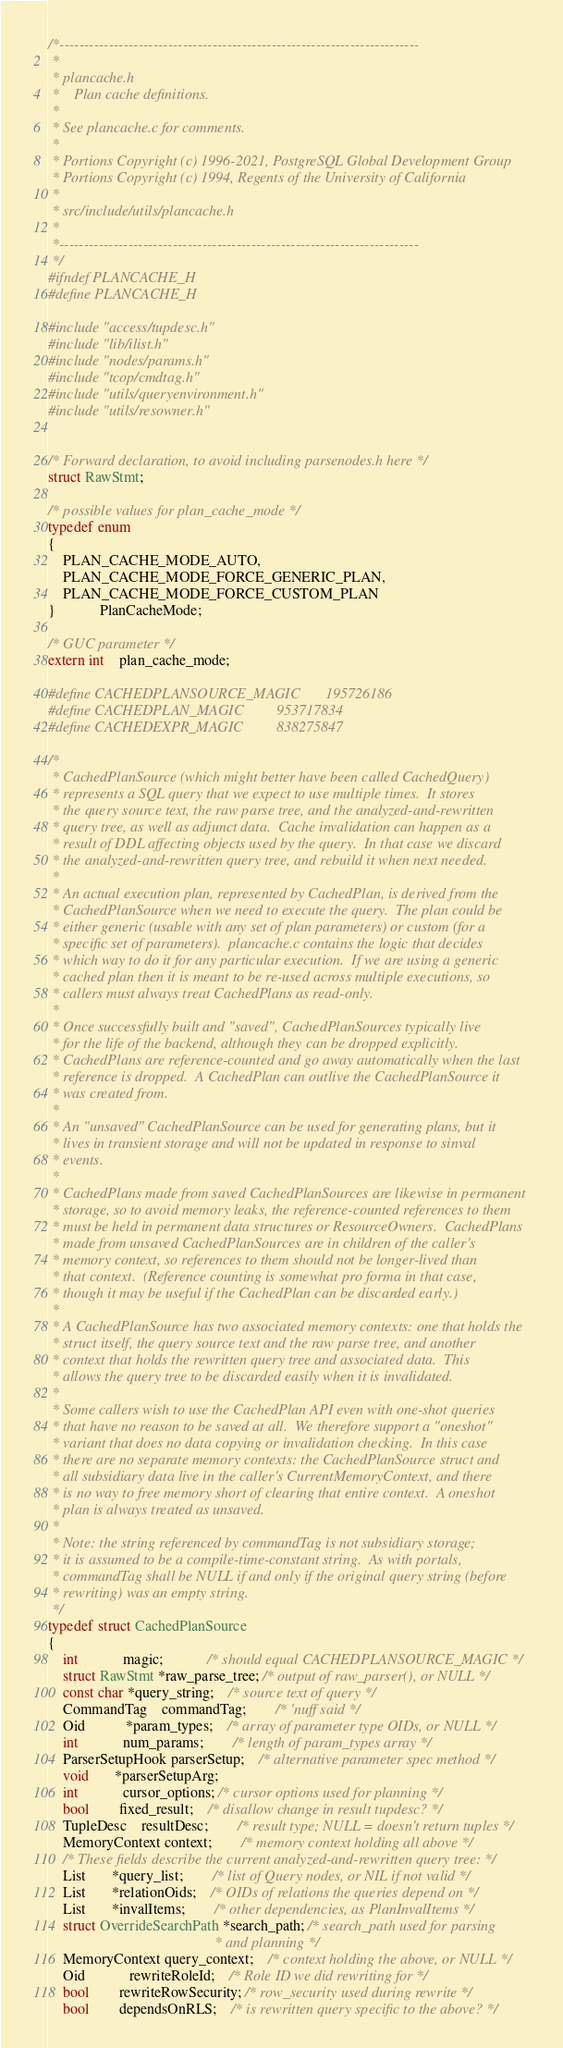<code> <loc_0><loc_0><loc_500><loc_500><_C_>/*-------------------------------------------------------------------------
 *
 * plancache.h
 *	  Plan cache definitions.
 *
 * See plancache.c for comments.
 *
 * Portions Copyright (c) 1996-2021, PostgreSQL Global Development Group
 * Portions Copyright (c) 1994, Regents of the University of California
 *
 * src/include/utils/plancache.h
 *
 *-------------------------------------------------------------------------
 */
#ifndef PLANCACHE_H
#define PLANCACHE_H

#include "access/tupdesc.h"
#include "lib/ilist.h"
#include "nodes/params.h"
#include "tcop/cmdtag.h"
#include "utils/queryenvironment.h"
#include "utils/resowner.h"


/* Forward declaration, to avoid including parsenodes.h here */
struct RawStmt;

/* possible values for plan_cache_mode */
typedef enum
{
	PLAN_CACHE_MODE_AUTO,
	PLAN_CACHE_MODE_FORCE_GENERIC_PLAN,
	PLAN_CACHE_MODE_FORCE_CUSTOM_PLAN
}			PlanCacheMode;

/* GUC parameter */
extern int	plan_cache_mode;

#define CACHEDPLANSOURCE_MAGIC		195726186
#define CACHEDPLAN_MAGIC			953717834
#define CACHEDEXPR_MAGIC			838275847

/*
 * CachedPlanSource (which might better have been called CachedQuery)
 * represents a SQL query that we expect to use multiple times.  It stores
 * the query source text, the raw parse tree, and the analyzed-and-rewritten
 * query tree, as well as adjunct data.  Cache invalidation can happen as a
 * result of DDL affecting objects used by the query.  In that case we discard
 * the analyzed-and-rewritten query tree, and rebuild it when next needed.
 *
 * An actual execution plan, represented by CachedPlan, is derived from the
 * CachedPlanSource when we need to execute the query.  The plan could be
 * either generic (usable with any set of plan parameters) or custom (for a
 * specific set of parameters).  plancache.c contains the logic that decides
 * which way to do it for any particular execution.  If we are using a generic
 * cached plan then it is meant to be re-used across multiple executions, so
 * callers must always treat CachedPlans as read-only.
 *
 * Once successfully built and "saved", CachedPlanSources typically live
 * for the life of the backend, although they can be dropped explicitly.
 * CachedPlans are reference-counted and go away automatically when the last
 * reference is dropped.  A CachedPlan can outlive the CachedPlanSource it
 * was created from.
 *
 * An "unsaved" CachedPlanSource can be used for generating plans, but it
 * lives in transient storage and will not be updated in response to sinval
 * events.
 *
 * CachedPlans made from saved CachedPlanSources are likewise in permanent
 * storage, so to avoid memory leaks, the reference-counted references to them
 * must be held in permanent data structures or ResourceOwners.  CachedPlans
 * made from unsaved CachedPlanSources are in children of the caller's
 * memory context, so references to them should not be longer-lived than
 * that context.  (Reference counting is somewhat pro forma in that case,
 * though it may be useful if the CachedPlan can be discarded early.)
 *
 * A CachedPlanSource has two associated memory contexts: one that holds the
 * struct itself, the query source text and the raw parse tree, and another
 * context that holds the rewritten query tree and associated data.  This
 * allows the query tree to be discarded easily when it is invalidated.
 *
 * Some callers wish to use the CachedPlan API even with one-shot queries
 * that have no reason to be saved at all.  We therefore support a "oneshot"
 * variant that does no data copying or invalidation checking.  In this case
 * there are no separate memory contexts: the CachedPlanSource struct and
 * all subsidiary data live in the caller's CurrentMemoryContext, and there
 * is no way to free memory short of clearing that entire context.  A oneshot
 * plan is always treated as unsaved.
 *
 * Note: the string referenced by commandTag is not subsidiary storage;
 * it is assumed to be a compile-time-constant string.  As with portals,
 * commandTag shall be NULL if and only if the original query string (before
 * rewriting) was an empty string.
 */
typedef struct CachedPlanSource
{
	int			magic;			/* should equal CACHEDPLANSOURCE_MAGIC */
	struct RawStmt *raw_parse_tree; /* output of raw_parser(), or NULL */
	const char *query_string;	/* source text of query */
	CommandTag	commandTag;		/* 'nuff said */
	Oid		   *param_types;	/* array of parameter type OIDs, or NULL */
	int			num_params;		/* length of param_types array */
	ParserSetupHook parserSetup;	/* alternative parameter spec method */
	void	   *parserSetupArg;
	int			cursor_options; /* cursor options used for planning */
	bool		fixed_result;	/* disallow change in result tupdesc? */
	TupleDesc	resultDesc;		/* result type; NULL = doesn't return tuples */
	MemoryContext context;		/* memory context holding all above */
	/* These fields describe the current analyzed-and-rewritten query tree: */
	List	   *query_list;		/* list of Query nodes, or NIL if not valid */
	List	   *relationOids;	/* OIDs of relations the queries depend on */
	List	   *invalItems;		/* other dependencies, as PlanInvalItems */
	struct OverrideSearchPath *search_path; /* search_path used for parsing
											 * and planning */
	MemoryContext query_context;	/* context holding the above, or NULL */
	Oid			rewriteRoleId;	/* Role ID we did rewriting for */
	bool		rewriteRowSecurity; /* row_security used during rewrite */
	bool		dependsOnRLS;	/* is rewritten query specific to the above? */</code> 